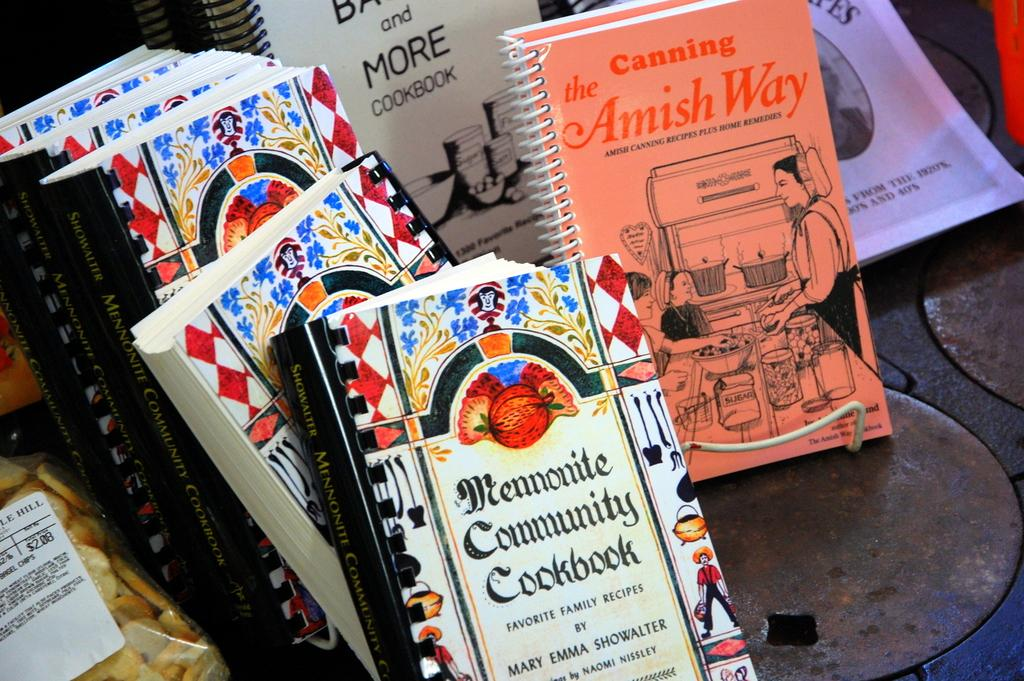Provide a one-sentence caption for the provided image. A book titled The Amish Way is among a stack of cookbooks. 